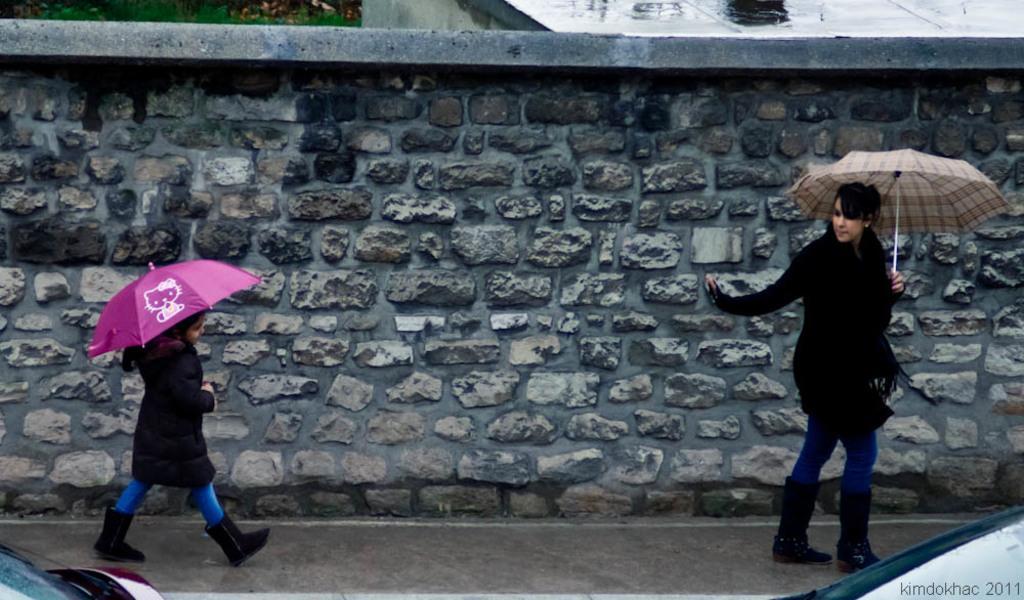Can you describe this image briefly? Here we can see two persons holding umbrellas. There are vehicles. In the background we can see a wall. 